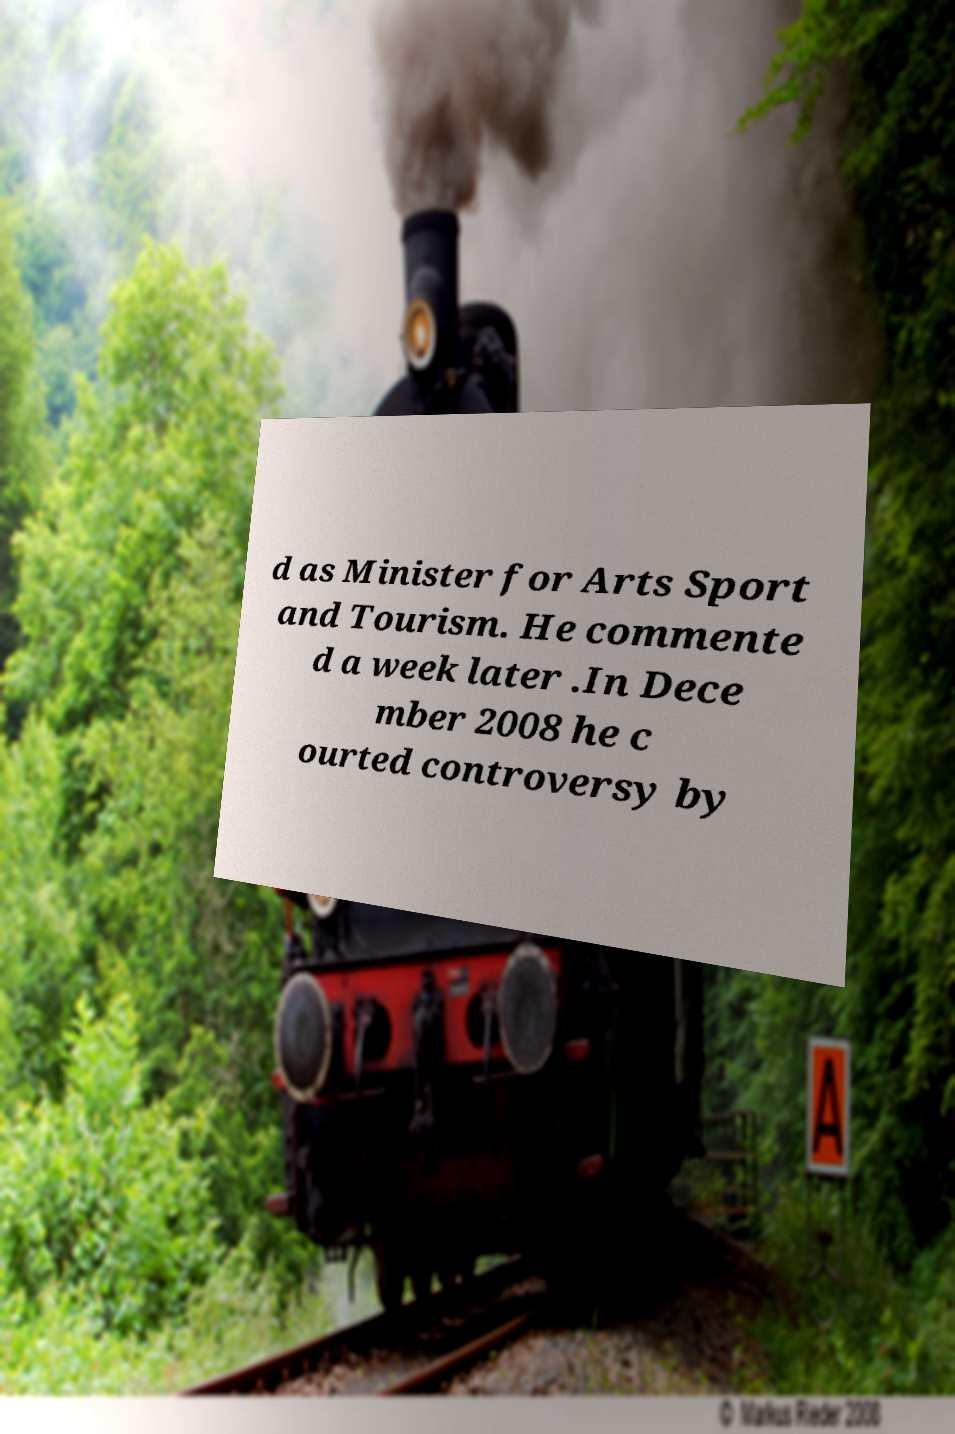For documentation purposes, I need the text within this image transcribed. Could you provide that? d as Minister for Arts Sport and Tourism. He commente d a week later .In Dece mber 2008 he c ourted controversy by 